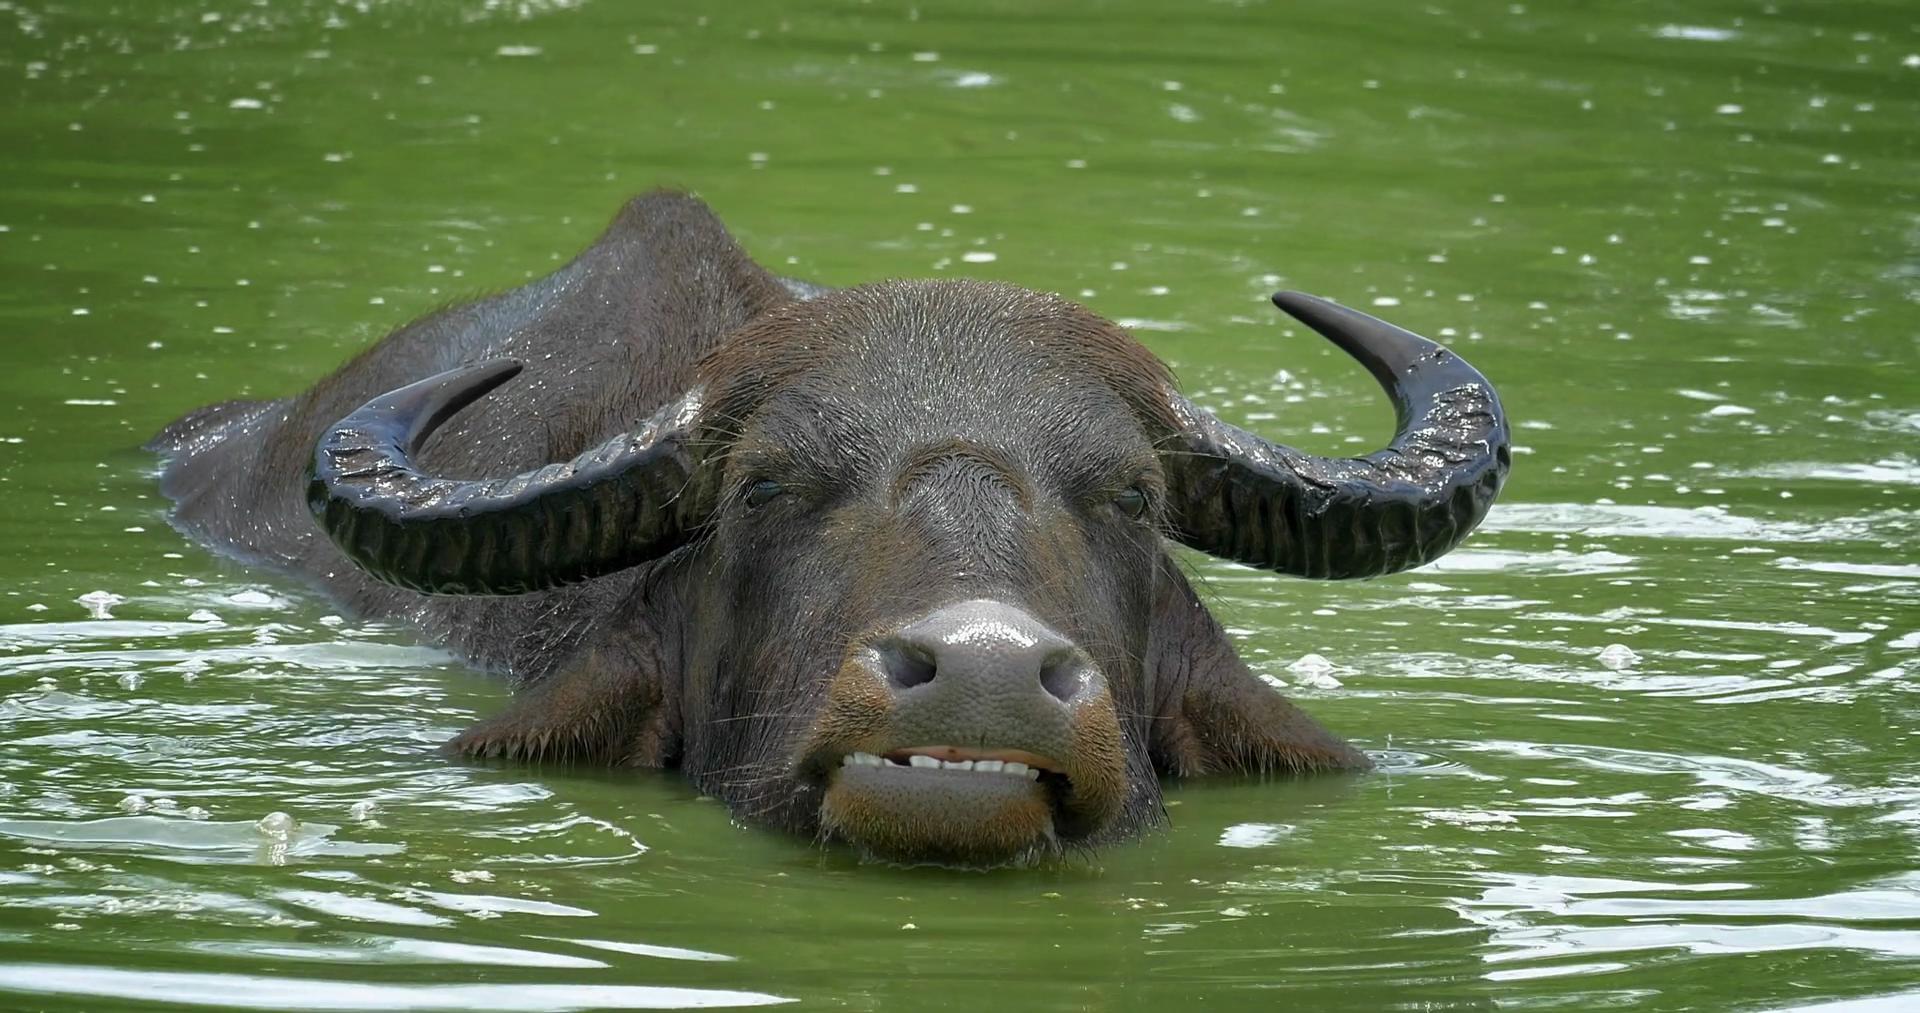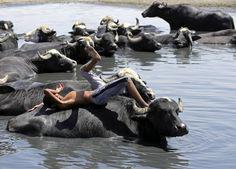The first image is the image on the left, the second image is the image on the right. Analyze the images presented: Is the assertion "All images show water buffalo in the water, and one image shows at least one young male in the scene with water buffalo." valid? Answer yes or no. Yes. The first image is the image on the left, the second image is the image on the right. For the images shown, is this caption "One the left image there is only one water buffalo." true? Answer yes or no. Yes. 